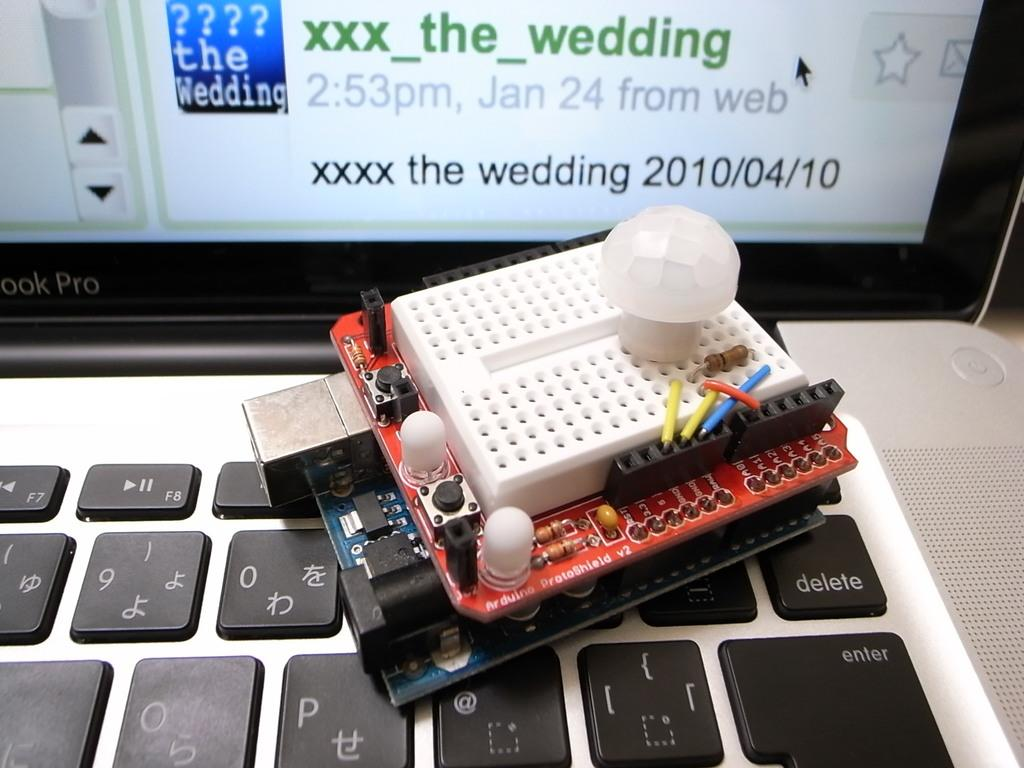<image>
Provide a brief description of the given image. a keyboard, monitor and circuit and the words the wedding visible. 